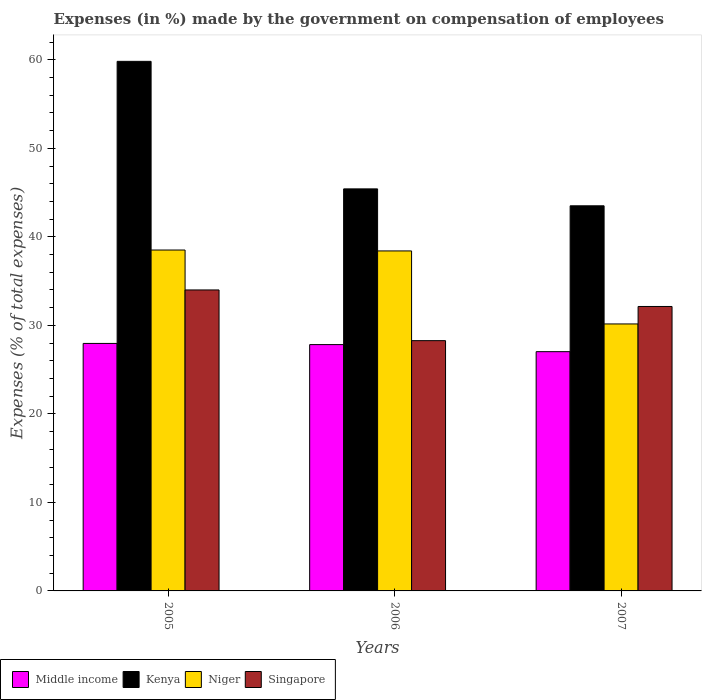Are the number of bars per tick equal to the number of legend labels?
Make the answer very short. Yes. How many bars are there on the 1st tick from the left?
Provide a short and direct response. 4. How many bars are there on the 2nd tick from the right?
Ensure brevity in your answer.  4. What is the label of the 3rd group of bars from the left?
Offer a very short reply. 2007. What is the percentage of expenses made by the government on compensation of employees in Kenya in 2006?
Offer a very short reply. 45.42. Across all years, what is the maximum percentage of expenses made by the government on compensation of employees in Kenya?
Your response must be concise. 59.83. Across all years, what is the minimum percentage of expenses made by the government on compensation of employees in Singapore?
Offer a very short reply. 28.28. In which year was the percentage of expenses made by the government on compensation of employees in Kenya maximum?
Give a very brief answer. 2005. In which year was the percentage of expenses made by the government on compensation of employees in Kenya minimum?
Ensure brevity in your answer.  2007. What is the total percentage of expenses made by the government on compensation of employees in Niger in the graph?
Keep it short and to the point. 107.09. What is the difference between the percentage of expenses made by the government on compensation of employees in Middle income in 2006 and that in 2007?
Make the answer very short. 0.8. What is the difference between the percentage of expenses made by the government on compensation of employees in Kenya in 2005 and the percentage of expenses made by the government on compensation of employees in Niger in 2006?
Provide a short and direct response. 21.42. What is the average percentage of expenses made by the government on compensation of employees in Niger per year?
Offer a terse response. 35.7. In the year 2006, what is the difference between the percentage of expenses made by the government on compensation of employees in Singapore and percentage of expenses made by the government on compensation of employees in Niger?
Provide a short and direct response. -10.14. What is the ratio of the percentage of expenses made by the government on compensation of employees in Middle income in 2006 to that in 2007?
Provide a short and direct response. 1.03. Is the percentage of expenses made by the government on compensation of employees in Singapore in 2005 less than that in 2006?
Your answer should be very brief. No. Is the difference between the percentage of expenses made by the government on compensation of employees in Singapore in 2006 and 2007 greater than the difference between the percentage of expenses made by the government on compensation of employees in Niger in 2006 and 2007?
Your answer should be very brief. No. What is the difference between the highest and the second highest percentage of expenses made by the government on compensation of employees in Middle income?
Ensure brevity in your answer.  0.13. What is the difference between the highest and the lowest percentage of expenses made by the government on compensation of employees in Kenya?
Give a very brief answer. 16.32. In how many years, is the percentage of expenses made by the government on compensation of employees in Niger greater than the average percentage of expenses made by the government on compensation of employees in Niger taken over all years?
Your answer should be very brief. 2. What does the 3rd bar from the left in 2005 represents?
Offer a very short reply. Niger. Is it the case that in every year, the sum of the percentage of expenses made by the government on compensation of employees in Niger and percentage of expenses made by the government on compensation of employees in Middle income is greater than the percentage of expenses made by the government on compensation of employees in Singapore?
Make the answer very short. Yes. What is the difference between two consecutive major ticks on the Y-axis?
Ensure brevity in your answer.  10. Does the graph contain any zero values?
Your response must be concise. No. Where does the legend appear in the graph?
Give a very brief answer. Bottom left. What is the title of the graph?
Ensure brevity in your answer.  Expenses (in %) made by the government on compensation of employees. Does "Norway" appear as one of the legend labels in the graph?
Provide a succinct answer. No. What is the label or title of the X-axis?
Your answer should be very brief. Years. What is the label or title of the Y-axis?
Your response must be concise. Expenses (% of total expenses). What is the Expenses (% of total expenses) of Middle income in 2005?
Your answer should be compact. 27.96. What is the Expenses (% of total expenses) of Kenya in 2005?
Your answer should be very brief. 59.83. What is the Expenses (% of total expenses) of Niger in 2005?
Your answer should be compact. 38.51. What is the Expenses (% of total expenses) of Singapore in 2005?
Offer a very short reply. 34.01. What is the Expenses (% of total expenses) of Middle income in 2006?
Offer a very short reply. 27.83. What is the Expenses (% of total expenses) of Kenya in 2006?
Keep it short and to the point. 45.42. What is the Expenses (% of total expenses) of Niger in 2006?
Give a very brief answer. 38.41. What is the Expenses (% of total expenses) in Singapore in 2006?
Give a very brief answer. 28.28. What is the Expenses (% of total expenses) of Middle income in 2007?
Provide a short and direct response. 27.03. What is the Expenses (% of total expenses) of Kenya in 2007?
Offer a terse response. 43.51. What is the Expenses (% of total expenses) in Niger in 2007?
Your answer should be very brief. 30.16. What is the Expenses (% of total expenses) of Singapore in 2007?
Provide a succinct answer. 32.14. Across all years, what is the maximum Expenses (% of total expenses) in Middle income?
Your answer should be very brief. 27.96. Across all years, what is the maximum Expenses (% of total expenses) of Kenya?
Offer a terse response. 59.83. Across all years, what is the maximum Expenses (% of total expenses) in Niger?
Your response must be concise. 38.51. Across all years, what is the maximum Expenses (% of total expenses) of Singapore?
Your answer should be compact. 34.01. Across all years, what is the minimum Expenses (% of total expenses) in Middle income?
Ensure brevity in your answer.  27.03. Across all years, what is the minimum Expenses (% of total expenses) of Kenya?
Offer a terse response. 43.51. Across all years, what is the minimum Expenses (% of total expenses) of Niger?
Keep it short and to the point. 30.16. Across all years, what is the minimum Expenses (% of total expenses) in Singapore?
Your response must be concise. 28.28. What is the total Expenses (% of total expenses) in Middle income in the graph?
Your answer should be compact. 82.82. What is the total Expenses (% of total expenses) in Kenya in the graph?
Keep it short and to the point. 148.77. What is the total Expenses (% of total expenses) of Niger in the graph?
Your answer should be very brief. 107.09. What is the total Expenses (% of total expenses) of Singapore in the graph?
Provide a succinct answer. 94.42. What is the difference between the Expenses (% of total expenses) of Middle income in 2005 and that in 2006?
Provide a short and direct response. 0.13. What is the difference between the Expenses (% of total expenses) of Kenya in 2005 and that in 2006?
Provide a succinct answer. 14.41. What is the difference between the Expenses (% of total expenses) in Niger in 2005 and that in 2006?
Offer a terse response. 0.1. What is the difference between the Expenses (% of total expenses) of Singapore in 2005 and that in 2006?
Ensure brevity in your answer.  5.73. What is the difference between the Expenses (% of total expenses) in Middle income in 2005 and that in 2007?
Your answer should be compact. 0.93. What is the difference between the Expenses (% of total expenses) in Kenya in 2005 and that in 2007?
Ensure brevity in your answer.  16.32. What is the difference between the Expenses (% of total expenses) of Niger in 2005 and that in 2007?
Provide a succinct answer. 8.35. What is the difference between the Expenses (% of total expenses) in Singapore in 2005 and that in 2007?
Ensure brevity in your answer.  1.87. What is the difference between the Expenses (% of total expenses) in Middle income in 2006 and that in 2007?
Provide a succinct answer. 0.8. What is the difference between the Expenses (% of total expenses) of Kenya in 2006 and that in 2007?
Offer a terse response. 1.91. What is the difference between the Expenses (% of total expenses) of Niger in 2006 and that in 2007?
Your response must be concise. 8.25. What is the difference between the Expenses (% of total expenses) in Singapore in 2006 and that in 2007?
Provide a short and direct response. -3.86. What is the difference between the Expenses (% of total expenses) in Middle income in 2005 and the Expenses (% of total expenses) in Kenya in 2006?
Offer a terse response. -17.46. What is the difference between the Expenses (% of total expenses) of Middle income in 2005 and the Expenses (% of total expenses) of Niger in 2006?
Your answer should be very brief. -10.45. What is the difference between the Expenses (% of total expenses) of Middle income in 2005 and the Expenses (% of total expenses) of Singapore in 2006?
Your answer should be compact. -0.31. What is the difference between the Expenses (% of total expenses) of Kenya in 2005 and the Expenses (% of total expenses) of Niger in 2006?
Provide a succinct answer. 21.42. What is the difference between the Expenses (% of total expenses) of Kenya in 2005 and the Expenses (% of total expenses) of Singapore in 2006?
Ensure brevity in your answer.  31.56. What is the difference between the Expenses (% of total expenses) of Niger in 2005 and the Expenses (% of total expenses) of Singapore in 2006?
Your answer should be compact. 10.24. What is the difference between the Expenses (% of total expenses) of Middle income in 2005 and the Expenses (% of total expenses) of Kenya in 2007?
Your answer should be very brief. -15.55. What is the difference between the Expenses (% of total expenses) of Middle income in 2005 and the Expenses (% of total expenses) of Niger in 2007?
Provide a short and direct response. -2.2. What is the difference between the Expenses (% of total expenses) of Middle income in 2005 and the Expenses (% of total expenses) of Singapore in 2007?
Provide a short and direct response. -4.18. What is the difference between the Expenses (% of total expenses) of Kenya in 2005 and the Expenses (% of total expenses) of Niger in 2007?
Ensure brevity in your answer.  29.67. What is the difference between the Expenses (% of total expenses) of Kenya in 2005 and the Expenses (% of total expenses) of Singapore in 2007?
Provide a succinct answer. 27.69. What is the difference between the Expenses (% of total expenses) of Niger in 2005 and the Expenses (% of total expenses) of Singapore in 2007?
Offer a very short reply. 6.38. What is the difference between the Expenses (% of total expenses) in Middle income in 2006 and the Expenses (% of total expenses) in Kenya in 2007?
Give a very brief answer. -15.68. What is the difference between the Expenses (% of total expenses) in Middle income in 2006 and the Expenses (% of total expenses) in Niger in 2007?
Ensure brevity in your answer.  -2.33. What is the difference between the Expenses (% of total expenses) of Middle income in 2006 and the Expenses (% of total expenses) of Singapore in 2007?
Give a very brief answer. -4.31. What is the difference between the Expenses (% of total expenses) of Kenya in 2006 and the Expenses (% of total expenses) of Niger in 2007?
Your answer should be compact. 15.26. What is the difference between the Expenses (% of total expenses) in Kenya in 2006 and the Expenses (% of total expenses) in Singapore in 2007?
Offer a very short reply. 13.29. What is the difference between the Expenses (% of total expenses) in Niger in 2006 and the Expenses (% of total expenses) in Singapore in 2007?
Your answer should be compact. 6.28. What is the average Expenses (% of total expenses) in Middle income per year?
Your answer should be compact. 27.61. What is the average Expenses (% of total expenses) in Kenya per year?
Give a very brief answer. 49.59. What is the average Expenses (% of total expenses) of Niger per year?
Ensure brevity in your answer.  35.7. What is the average Expenses (% of total expenses) of Singapore per year?
Offer a terse response. 31.47. In the year 2005, what is the difference between the Expenses (% of total expenses) in Middle income and Expenses (% of total expenses) in Kenya?
Offer a very short reply. -31.87. In the year 2005, what is the difference between the Expenses (% of total expenses) in Middle income and Expenses (% of total expenses) in Niger?
Give a very brief answer. -10.55. In the year 2005, what is the difference between the Expenses (% of total expenses) of Middle income and Expenses (% of total expenses) of Singapore?
Your answer should be compact. -6.04. In the year 2005, what is the difference between the Expenses (% of total expenses) of Kenya and Expenses (% of total expenses) of Niger?
Provide a short and direct response. 21.32. In the year 2005, what is the difference between the Expenses (% of total expenses) in Kenya and Expenses (% of total expenses) in Singapore?
Your answer should be compact. 25.83. In the year 2005, what is the difference between the Expenses (% of total expenses) in Niger and Expenses (% of total expenses) in Singapore?
Provide a succinct answer. 4.51. In the year 2006, what is the difference between the Expenses (% of total expenses) of Middle income and Expenses (% of total expenses) of Kenya?
Ensure brevity in your answer.  -17.59. In the year 2006, what is the difference between the Expenses (% of total expenses) in Middle income and Expenses (% of total expenses) in Niger?
Keep it short and to the point. -10.58. In the year 2006, what is the difference between the Expenses (% of total expenses) in Middle income and Expenses (% of total expenses) in Singapore?
Your answer should be very brief. -0.45. In the year 2006, what is the difference between the Expenses (% of total expenses) of Kenya and Expenses (% of total expenses) of Niger?
Offer a very short reply. 7.01. In the year 2006, what is the difference between the Expenses (% of total expenses) in Kenya and Expenses (% of total expenses) in Singapore?
Make the answer very short. 17.15. In the year 2006, what is the difference between the Expenses (% of total expenses) in Niger and Expenses (% of total expenses) in Singapore?
Your answer should be very brief. 10.14. In the year 2007, what is the difference between the Expenses (% of total expenses) in Middle income and Expenses (% of total expenses) in Kenya?
Your answer should be very brief. -16.48. In the year 2007, what is the difference between the Expenses (% of total expenses) in Middle income and Expenses (% of total expenses) in Niger?
Provide a short and direct response. -3.13. In the year 2007, what is the difference between the Expenses (% of total expenses) in Middle income and Expenses (% of total expenses) in Singapore?
Give a very brief answer. -5.11. In the year 2007, what is the difference between the Expenses (% of total expenses) of Kenya and Expenses (% of total expenses) of Niger?
Your answer should be very brief. 13.35. In the year 2007, what is the difference between the Expenses (% of total expenses) in Kenya and Expenses (% of total expenses) in Singapore?
Ensure brevity in your answer.  11.37. In the year 2007, what is the difference between the Expenses (% of total expenses) of Niger and Expenses (% of total expenses) of Singapore?
Ensure brevity in your answer.  -1.97. What is the ratio of the Expenses (% of total expenses) in Middle income in 2005 to that in 2006?
Provide a short and direct response. 1. What is the ratio of the Expenses (% of total expenses) in Kenya in 2005 to that in 2006?
Keep it short and to the point. 1.32. What is the ratio of the Expenses (% of total expenses) of Singapore in 2005 to that in 2006?
Your response must be concise. 1.2. What is the ratio of the Expenses (% of total expenses) of Middle income in 2005 to that in 2007?
Offer a very short reply. 1.03. What is the ratio of the Expenses (% of total expenses) in Kenya in 2005 to that in 2007?
Give a very brief answer. 1.38. What is the ratio of the Expenses (% of total expenses) in Niger in 2005 to that in 2007?
Your response must be concise. 1.28. What is the ratio of the Expenses (% of total expenses) in Singapore in 2005 to that in 2007?
Your response must be concise. 1.06. What is the ratio of the Expenses (% of total expenses) in Middle income in 2006 to that in 2007?
Make the answer very short. 1.03. What is the ratio of the Expenses (% of total expenses) in Kenya in 2006 to that in 2007?
Keep it short and to the point. 1.04. What is the ratio of the Expenses (% of total expenses) of Niger in 2006 to that in 2007?
Make the answer very short. 1.27. What is the ratio of the Expenses (% of total expenses) in Singapore in 2006 to that in 2007?
Your response must be concise. 0.88. What is the difference between the highest and the second highest Expenses (% of total expenses) in Middle income?
Ensure brevity in your answer.  0.13. What is the difference between the highest and the second highest Expenses (% of total expenses) of Kenya?
Your answer should be very brief. 14.41. What is the difference between the highest and the second highest Expenses (% of total expenses) of Niger?
Provide a succinct answer. 0.1. What is the difference between the highest and the second highest Expenses (% of total expenses) in Singapore?
Give a very brief answer. 1.87. What is the difference between the highest and the lowest Expenses (% of total expenses) of Middle income?
Your answer should be very brief. 0.93. What is the difference between the highest and the lowest Expenses (% of total expenses) of Kenya?
Provide a succinct answer. 16.32. What is the difference between the highest and the lowest Expenses (% of total expenses) in Niger?
Make the answer very short. 8.35. What is the difference between the highest and the lowest Expenses (% of total expenses) in Singapore?
Make the answer very short. 5.73. 